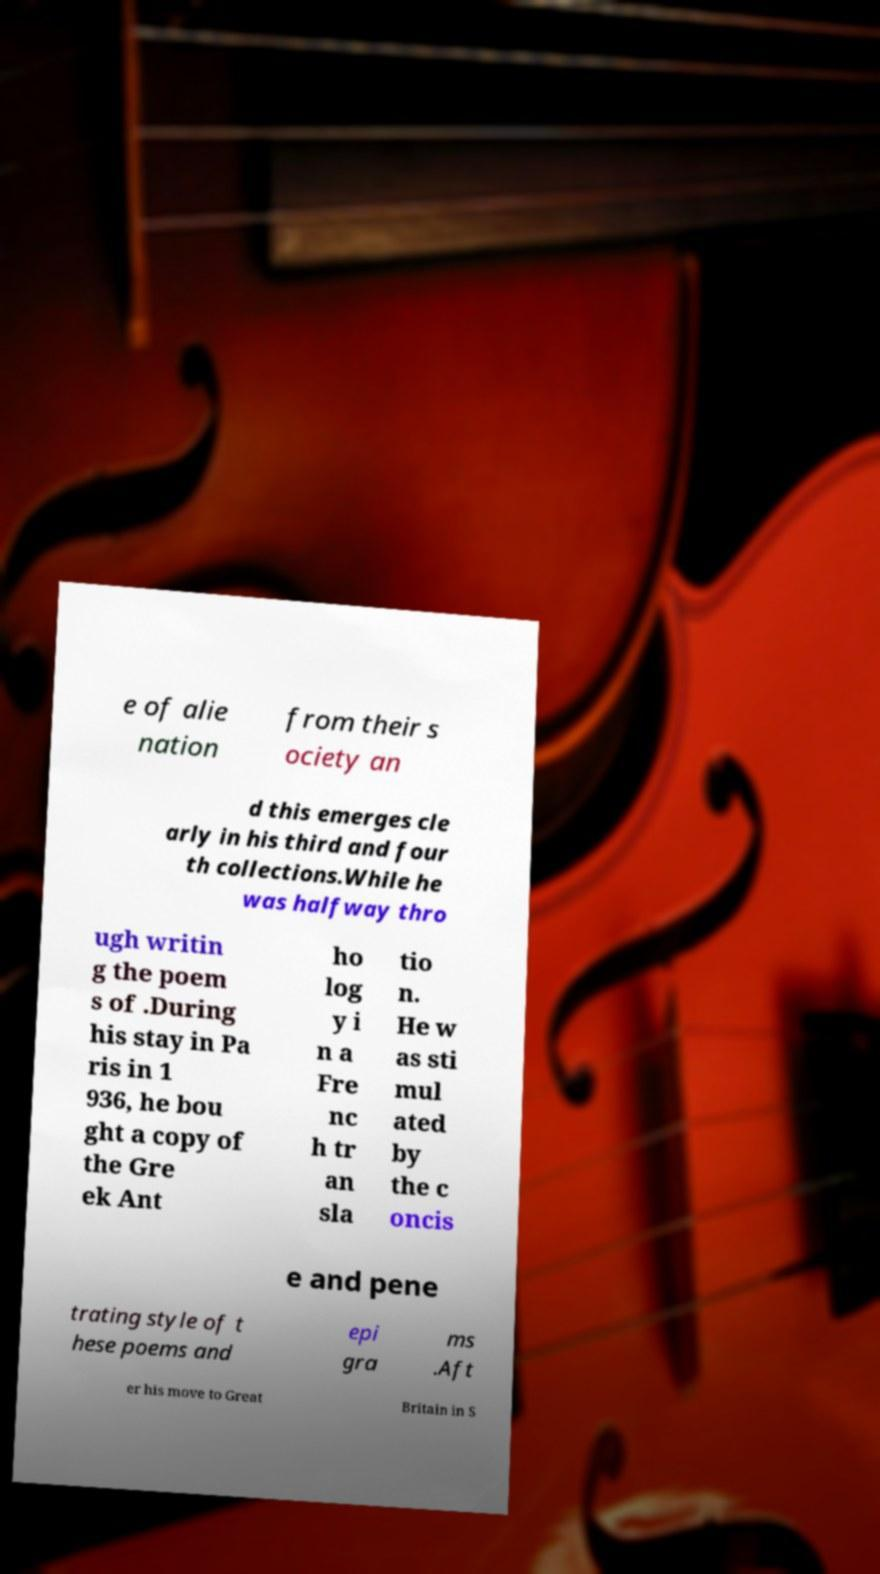Can you accurately transcribe the text from the provided image for me? e of alie nation from their s ociety an d this emerges cle arly in his third and four th collections.While he was halfway thro ugh writin g the poem s of .During his stay in Pa ris in 1 936, he bou ght a copy of the Gre ek Ant ho log y i n a Fre nc h tr an sla tio n. He w as sti mul ated by the c oncis e and pene trating style of t hese poems and epi gra ms .Aft er his move to Great Britain in S 